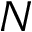<formula> <loc_0><loc_0><loc_500><loc_500>N</formula> 